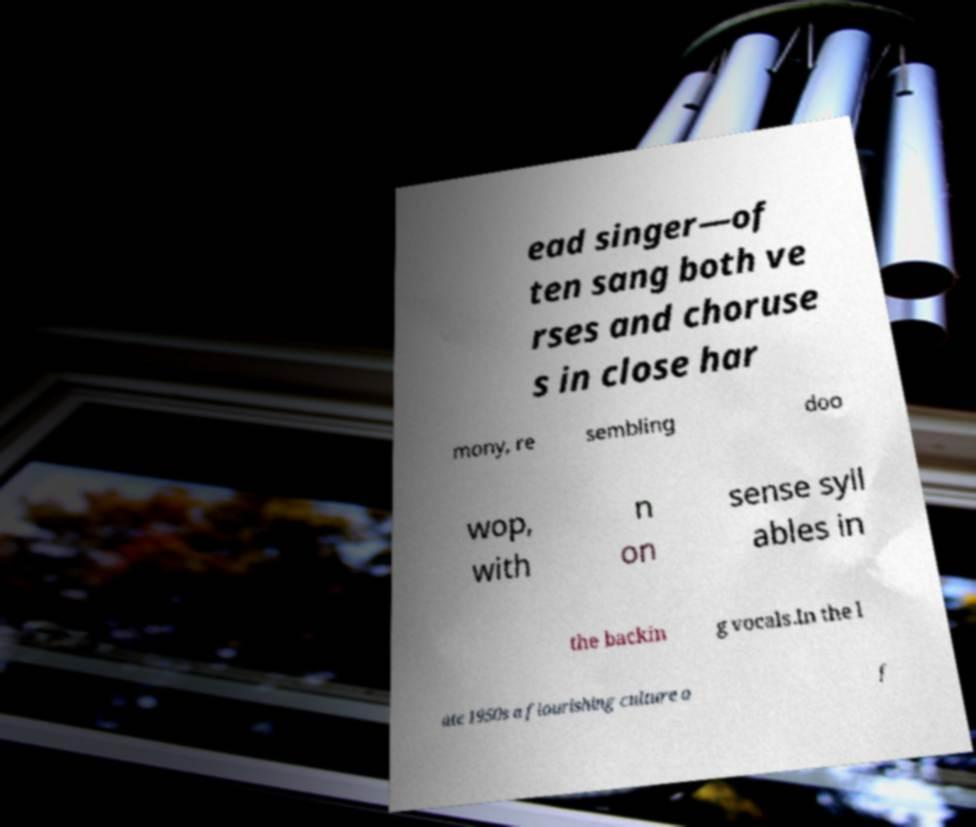I need the written content from this picture converted into text. Can you do that? ead singer—of ten sang both ve rses and choruse s in close har mony, re sembling doo wop, with n on sense syll ables in the backin g vocals.In the l ate 1950s a flourishing culture o f 